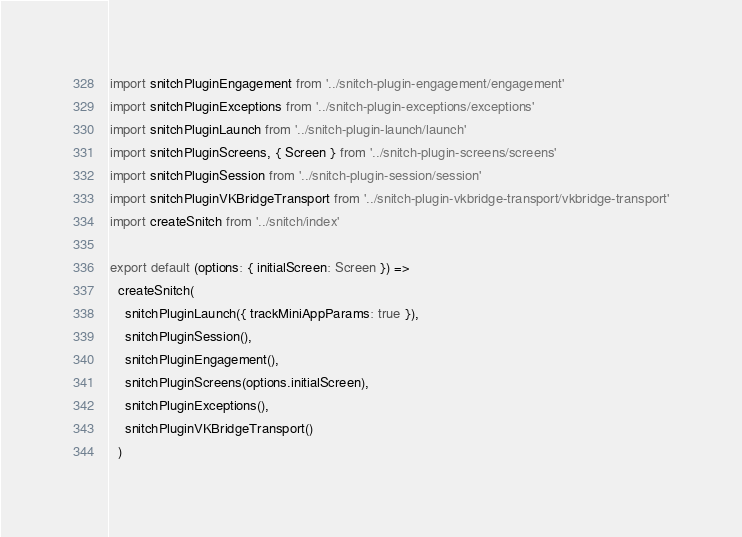<code> <loc_0><loc_0><loc_500><loc_500><_TypeScript_>import snitchPluginEngagement from '../snitch-plugin-engagement/engagement'
import snitchPluginExceptions from '../snitch-plugin-exceptions/exceptions'
import snitchPluginLaunch from '../snitch-plugin-launch/launch'
import snitchPluginScreens, { Screen } from '../snitch-plugin-screens/screens'
import snitchPluginSession from '../snitch-plugin-session/session'
import snitchPluginVKBridgeTransport from '../snitch-plugin-vkbridge-transport/vkbridge-transport'
import createSnitch from '../snitch/index'

export default (options: { initialScreen: Screen }) =>
  createSnitch(
    snitchPluginLaunch({ trackMiniAppParams: true }),
    snitchPluginSession(),
    snitchPluginEngagement(),
    snitchPluginScreens(options.initialScreen),
    snitchPluginExceptions(),
    snitchPluginVKBridgeTransport()
  )
</code> 